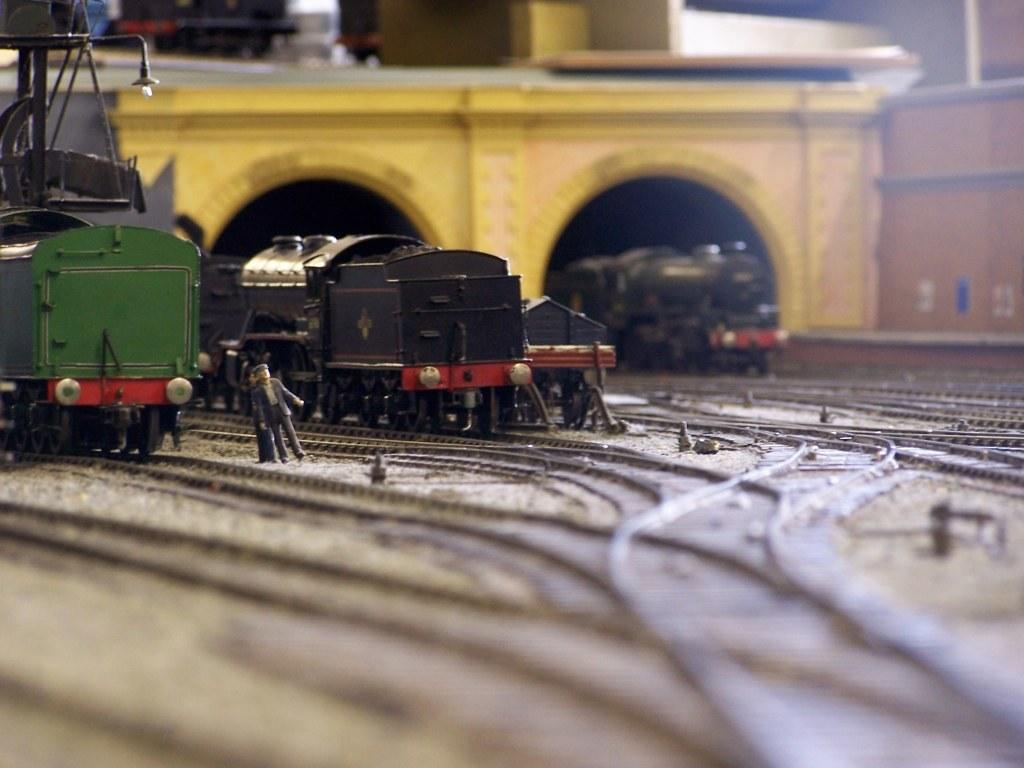What type of toy is present on the track in the image? There are toy trains on the track in the image. Can you describe the people in the image? There are people in the image, but their specific actions or characteristics are not mentioned in the facts. What can be seen in the background of the image? There is a bridge in the background of the image. What is the source of light in the image? There is a light visible in the image. How many toy trains can be seen in the image? There are other toy trains in the image, in addition to the ones on the track. What type of potato is being used as a decoration in the image? There is no potato present in the image; it features toy trains on a track, people, a bridge, and a light. Can you tell me how many goldfish are swimming in the image? There are no goldfish present in the image; it features toy trains on a track, people, a bridge, and a light. 